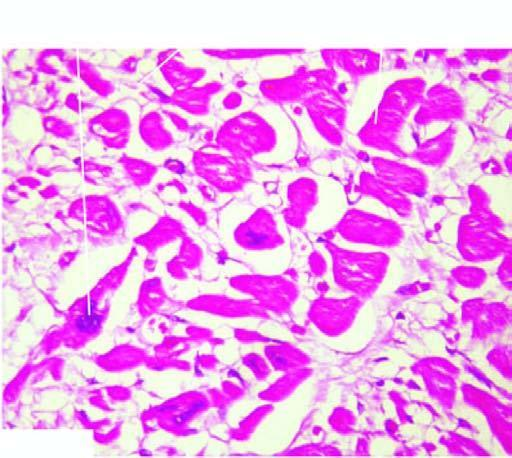how are the myocardial muscle fibres?
Answer the question using a single word or phrase. Thick with abundance of eosinophilic cytoplasm 